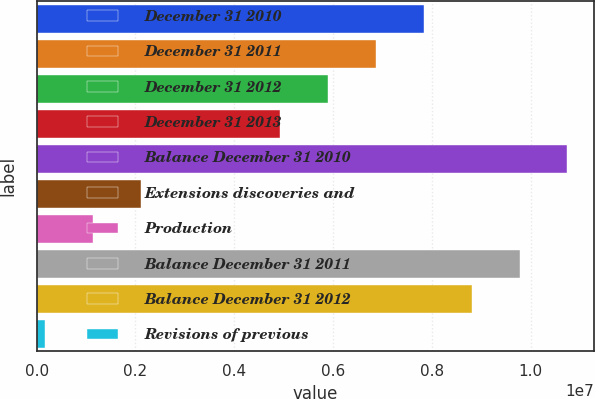Convert chart to OTSL. <chart><loc_0><loc_0><loc_500><loc_500><bar_chart><fcel>December 31 2010<fcel>December 31 2011<fcel>December 31 2012<fcel>December 31 2013<fcel>Balance December 31 2010<fcel>Extensions discoveries and<fcel>Production<fcel>Balance December 31 2011<fcel>Balance December 31 2012<fcel>Revisions of previous<nl><fcel>7.83426e+06<fcel>6.86486e+06<fcel>5.89546e+06<fcel>4.92606e+06<fcel>1.07425e+07<fcel>2.11199e+06<fcel>1.14259e+06<fcel>9.77306e+06<fcel>8.80366e+06<fcel>173191<nl></chart> 